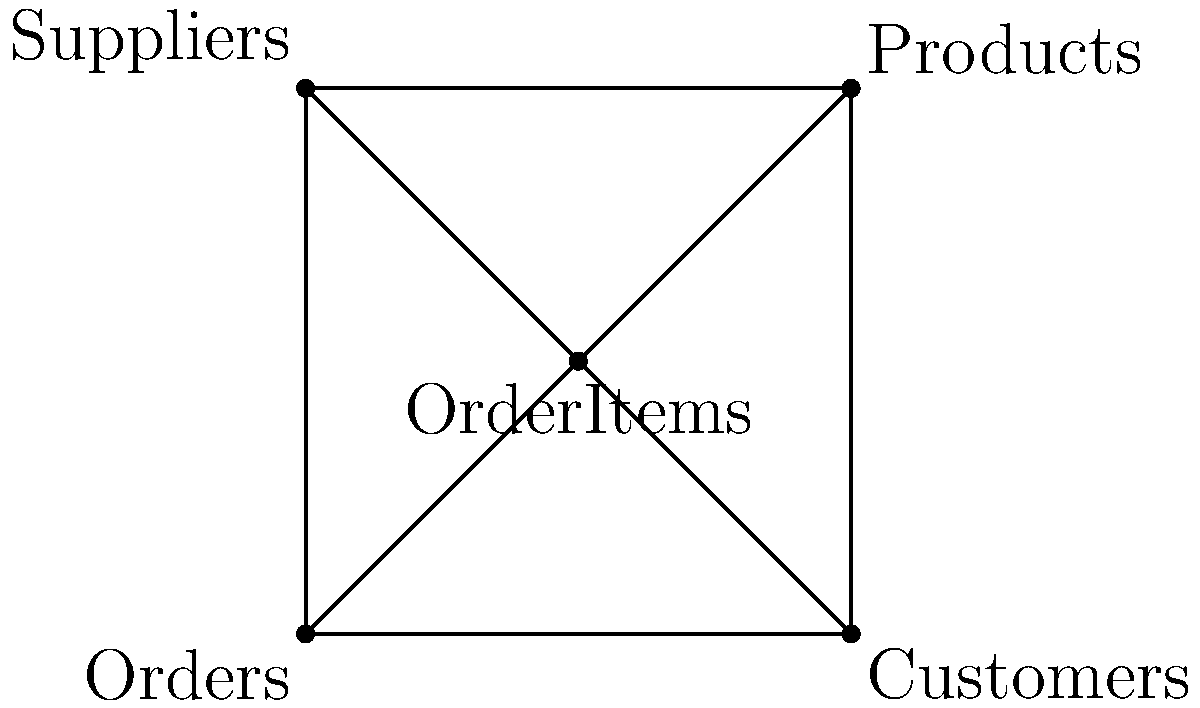Given the entity-relationship diagram above, which transformation would likely improve query performance when fetching order details with customer and product information? To optimize query performance for fetching order details with customer and product information, we need to consider the following steps:

1. Analyze the current structure:
   - The diagram shows a central "OrderItems" entity connected to "Orders", "Customers", "Products", and "Suppliers".
   - This structure may require multiple joins when querying order details with customer and product information.

2. Identify the most frequently accessed entities:
   - For order details with customer and product information, we primarily need "Orders", "Customers", and "Products".

3. Consider denormalization:
   - Denormalization involves adding redundant data to reduce the number of joins required in queries.
   - In this case, we can add customer and product information directly to the "Orders" table.

4. Proposed transformation:
   - Move relevant customer information (e.g., name, contact details) to the "Orders" table.
   - Move relevant product information (e.g., product name, price) to the "OrderItems" table.

5. Benefits of the transformation:
   - Reduces the number of joins required to fetch order details with customer and product information.
   - Improves query performance by reducing the complexity of the SQL statements.

6. Considerations:
   - This transformation may increase data redundancy and storage requirements.
   - It may also complicate data updates, as changes to customer or product information need to be propagated to multiple tables.

The optimal transformation would be to denormalize the schema by adding relevant customer information to the "Orders" table and product information to the "OrderItems" table.
Answer: Denormalize by adding customer info to Orders and product info to OrderItems 